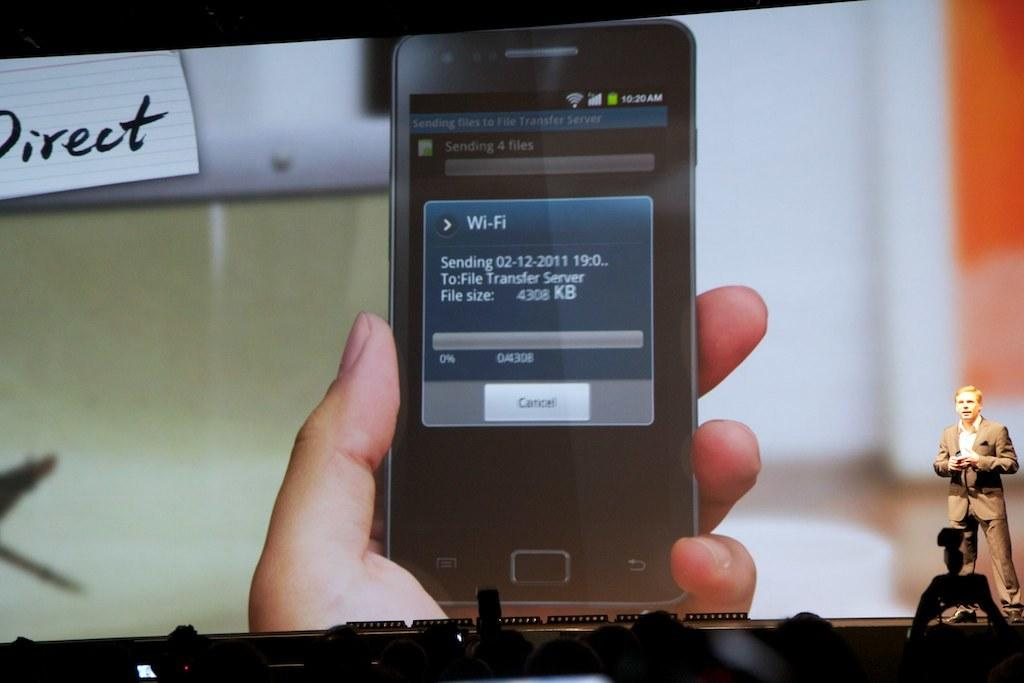<image>
Describe the image concisely. At a conference a phone is shown on the big screen with the word Direct at the top left. 